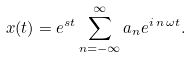Convert formula to latex. <formula><loc_0><loc_0><loc_500><loc_500>x ( t ) = e ^ { s t } \sum _ { n = - \infty } ^ { \infty } a _ { n } e ^ { i \, n \, \omega t } .</formula> 